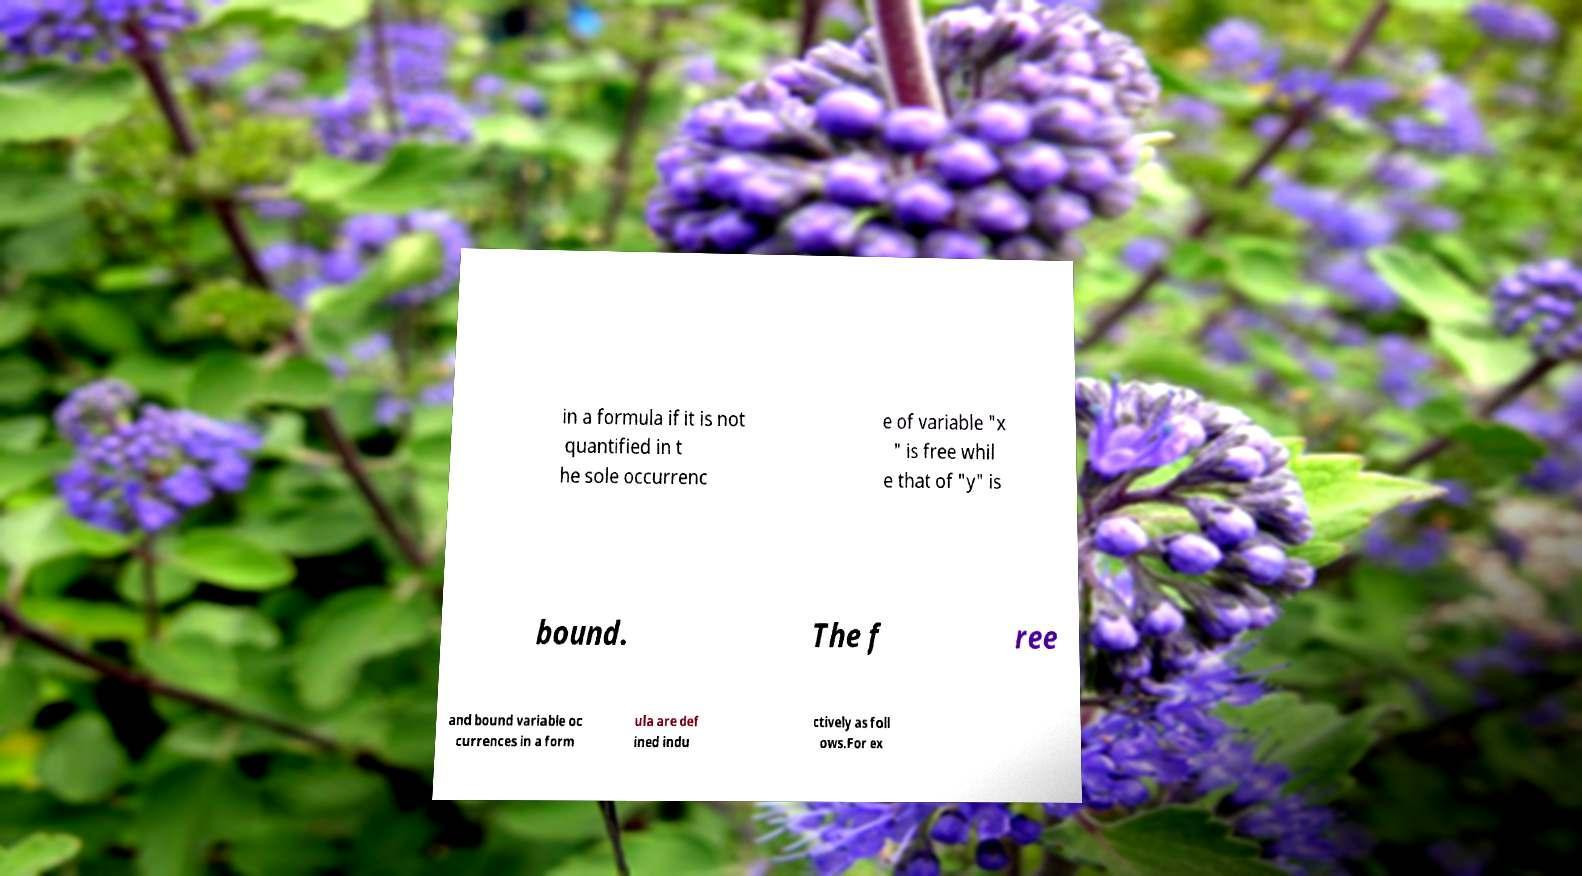Can you read and provide the text displayed in the image?This photo seems to have some interesting text. Can you extract and type it out for me? in a formula if it is not quantified in t he sole occurrenc e of variable "x " is free whil e that of "y" is bound. The f ree and bound variable oc currences in a form ula are def ined indu ctively as foll ows.For ex 